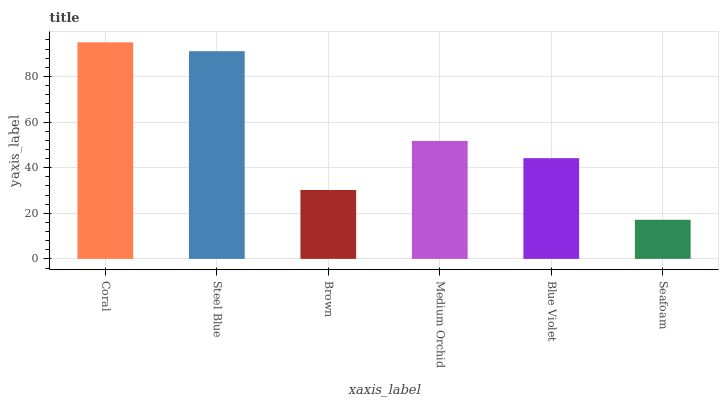Is Seafoam the minimum?
Answer yes or no. Yes. Is Coral the maximum?
Answer yes or no. Yes. Is Steel Blue the minimum?
Answer yes or no. No. Is Steel Blue the maximum?
Answer yes or no. No. Is Coral greater than Steel Blue?
Answer yes or no. Yes. Is Steel Blue less than Coral?
Answer yes or no. Yes. Is Steel Blue greater than Coral?
Answer yes or no. No. Is Coral less than Steel Blue?
Answer yes or no. No. Is Medium Orchid the high median?
Answer yes or no. Yes. Is Blue Violet the low median?
Answer yes or no. Yes. Is Coral the high median?
Answer yes or no. No. Is Coral the low median?
Answer yes or no. No. 